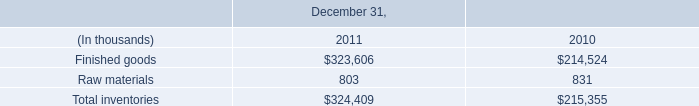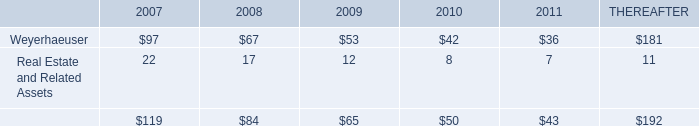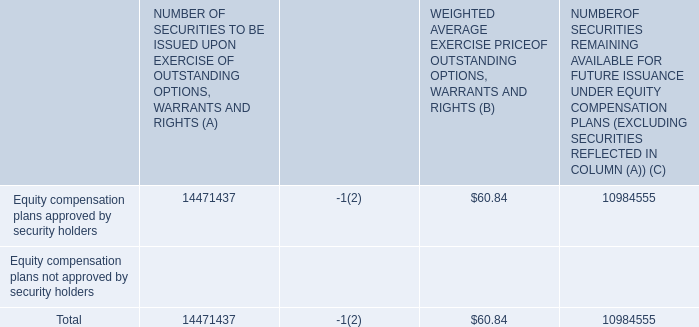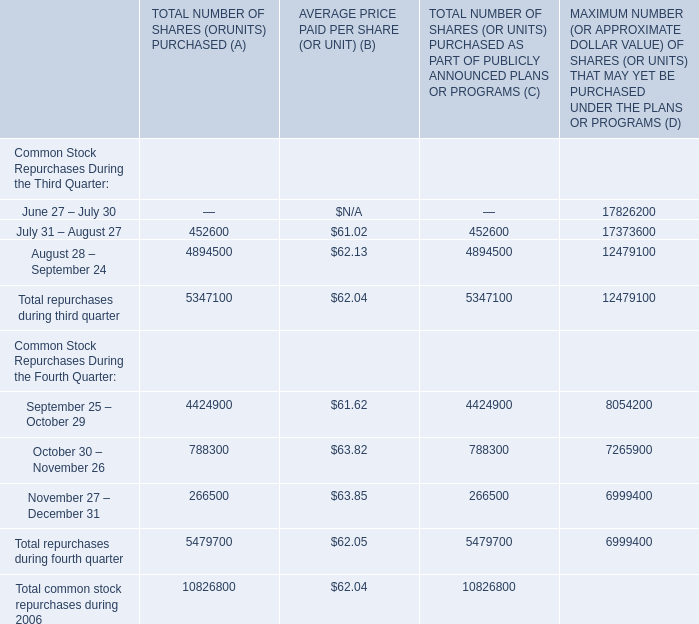as part of the july 2011 acquisition of the property what was the percent of the assumed loan to the purchase price 
Computations: (38.6 / 60.5)
Answer: 0.63802. What is the value of the WEIGHTED AVERAGE EXERCISE PRICE OF OUTSTANDING OPTIONS, WARRANTS AND RIGHTS (B) for Equity compensation plans approved by security holders? 
Answer: 60.84. 